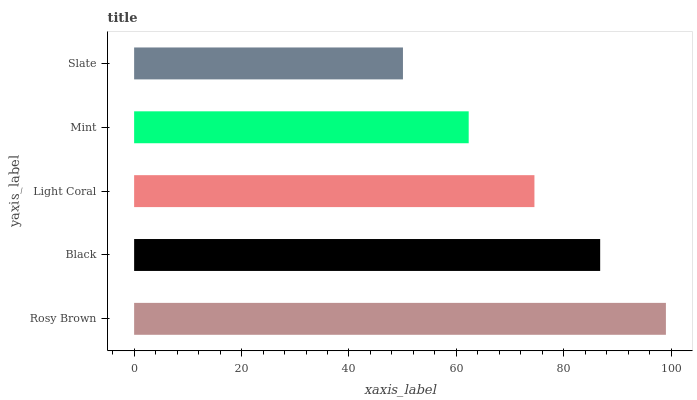Is Slate the minimum?
Answer yes or no. Yes. Is Rosy Brown the maximum?
Answer yes or no. Yes. Is Black the minimum?
Answer yes or no. No. Is Black the maximum?
Answer yes or no. No. Is Rosy Brown greater than Black?
Answer yes or no. Yes. Is Black less than Rosy Brown?
Answer yes or no. Yes. Is Black greater than Rosy Brown?
Answer yes or no. No. Is Rosy Brown less than Black?
Answer yes or no. No. Is Light Coral the high median?
Answer yes or no. Yes. Is Light Coral the low median?
Answer yes or no. Yes. Is Mint the high median?
Answer yes or no. No. Is Rosy Brown the low median?
Answer yes or no. No. 